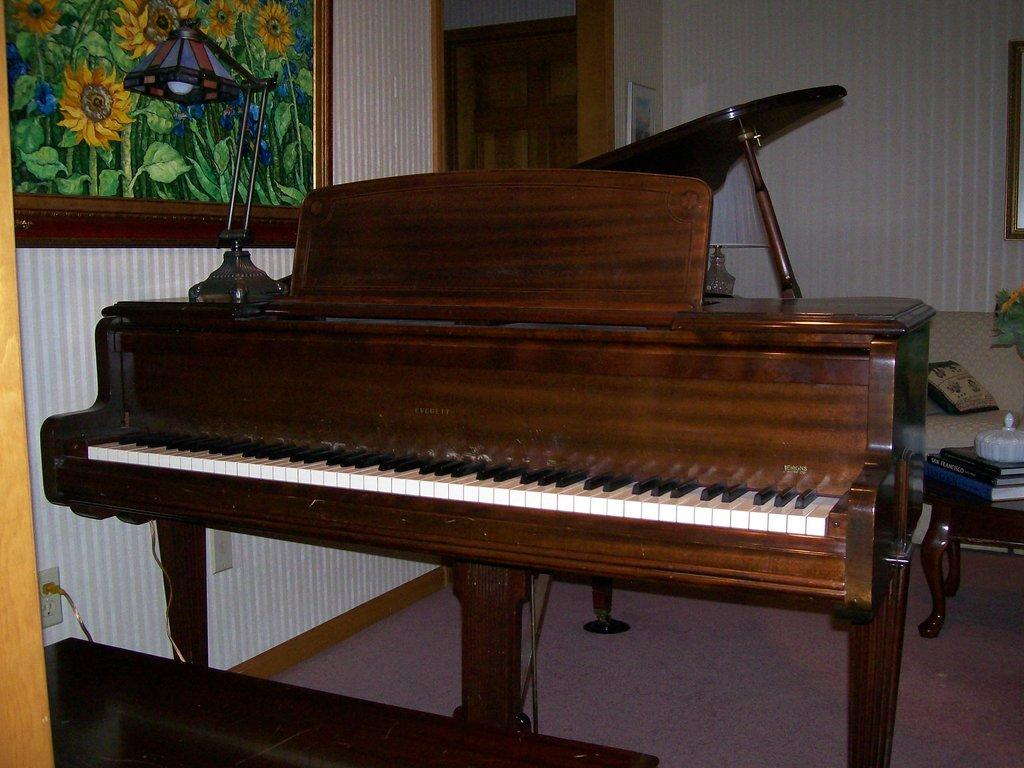What is the main object in the image? There is a piano in the image. What can be seen in the background of the image? There is a wall in the background of the image. What is attached to the wall? A photograph is attached to the wall. What is placed on top of the piano? There is a lamp on the piano. What type of yak can be seen grazing on the side of the piano in the image? There is no yak present in the image, and the piano is not located near a grazing area for yaks. 